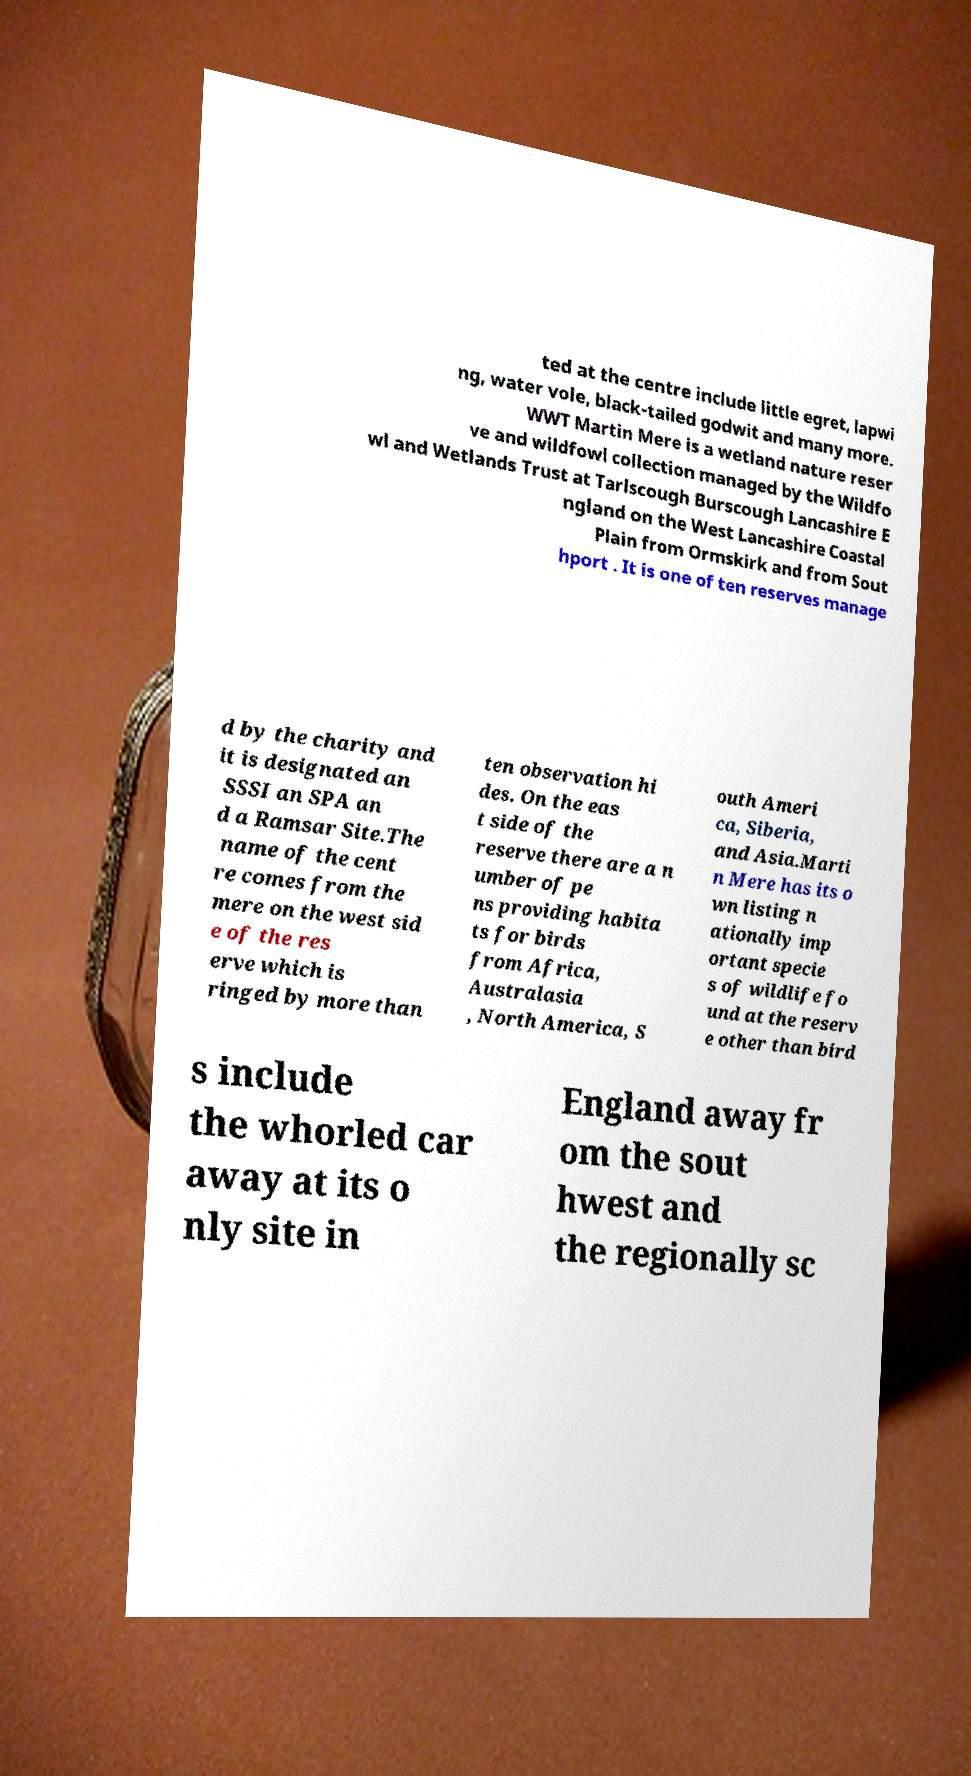Can you read and provide the text displayed in the image?This photo seems to have some interesting text. Can you extract and type it out for me? ted at the centre include little egret, lapwi ng, water vole, black-tailed godwit and many more. WWT Martin Mere is a wetland nature reser ve and wildfowl collection managed by the Wildfo wl and Wetlands Trust at Tarlscough Burscough Lancashire E ngland on the West Lancashire Coastal Plain from Ormskirk and from Sout hport . It is one of ten reserves manage d by the charity and it is designated an SSSI an SPA an d a Ramsar Site.The name of the cent re comes from the mere on the west sid e of the res erve which is ringed by more than ten observation hi des. On the eas t side of the reserve there are a n umber of pe ns providing habita ts for birds from Africa, Australasia , North America, S outh Ameri ca, Siberia, and Asia.Marti n Mere has its o wn listing n ationally imp ortant specie s of wildlife fo und at the reserv e other than bird s include the whorled car away at its o nly site in England away fr om the sout hwest and the regionally sc 